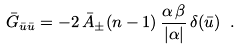Convert formula to latex. <formula><loc_0><loc_0><loc_500><loc_500>\bar { G } _ { \bar { u } \bar { u } } = - 2 \, \bar { A } _ { \pm } ( n - 1 ) \, \frac { \alpha \, \beta } { | \alpha | } \, \delta ( \bar { u } ) \ .</formula> 